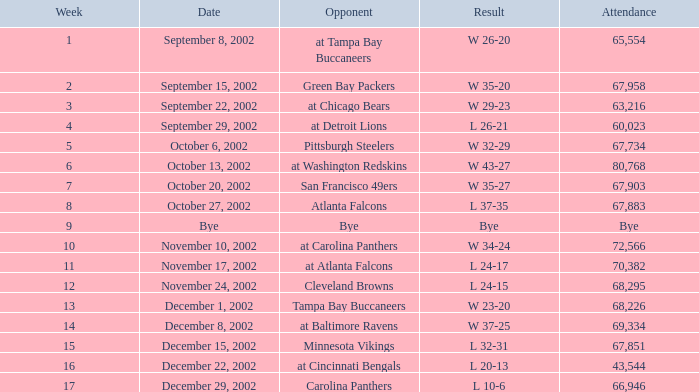Who was the opposing team in the game attended by 65,554? At tampa bay buccaneers. Could you help me parse every detail presented in this table? {'header': ['Week', 'Date', 'Opponent', 'Result', 'Attendance'], 'rows': [['1', 'September 8, 2002', 'at Tampa Bay Buccaneers', 'W 26-20', '65,554'], ['2', 'September 15, 2002', 'Green Bay Packers', 'W 35-20', '67,958'], ['3', 'September 22, 2002', 'at Chicago Bears', 'W 29-23', '63,216'], ['4', 'September 29, 2002', 'at Detroit Lions', 'L 26-21', '60,023'], ['5', 'October 6, 2002', 'Pittsburgh Steelers', 'W 32-29', '67,734'], ['6', 'October 13, 2002', 'at Washington Redskins', 'W 43-27', '80,768'], ['7', 'October 20, 2002', 'San Francisco 49ers', 'W 35-27', '67,903'], ['8', 'October 27, 2002', 'Atlanta Falcons', 'L 37-35', '67,883'], ['9', 'Bye', 'Bye', 'Bye', 'Bye'], ['10', 'November 10, 2002', 'at Carolina Panthers', 'W 34-24', '72,566'], ['11', 'November 17, 2002', 'at Atlanta Falcons', 'L 24-17', '70,382'], ['12', 'November 24, 2002', 'Cleveland Browns', 'L 24-15', '68,295'], ['13', 'December 1, 2002', 'Tampa Bay Buccaneers', 'W 23-20', '68,226'], ['14', 'December 8, 2002', 'at Baltimore Ravens', 'W 37-25', '69,334'], ['15', 'December 15, 2002', 'Minnesota Vikings', 'L 32-31', '67,851'], ['16', 'December 22, 2002', 'at Cincinnati Bengals', 'L 20-13', '43,544'], ['17', 'December 29, 2002', 'Carolina Panthers', 'L 10-6', '66,946']]} 